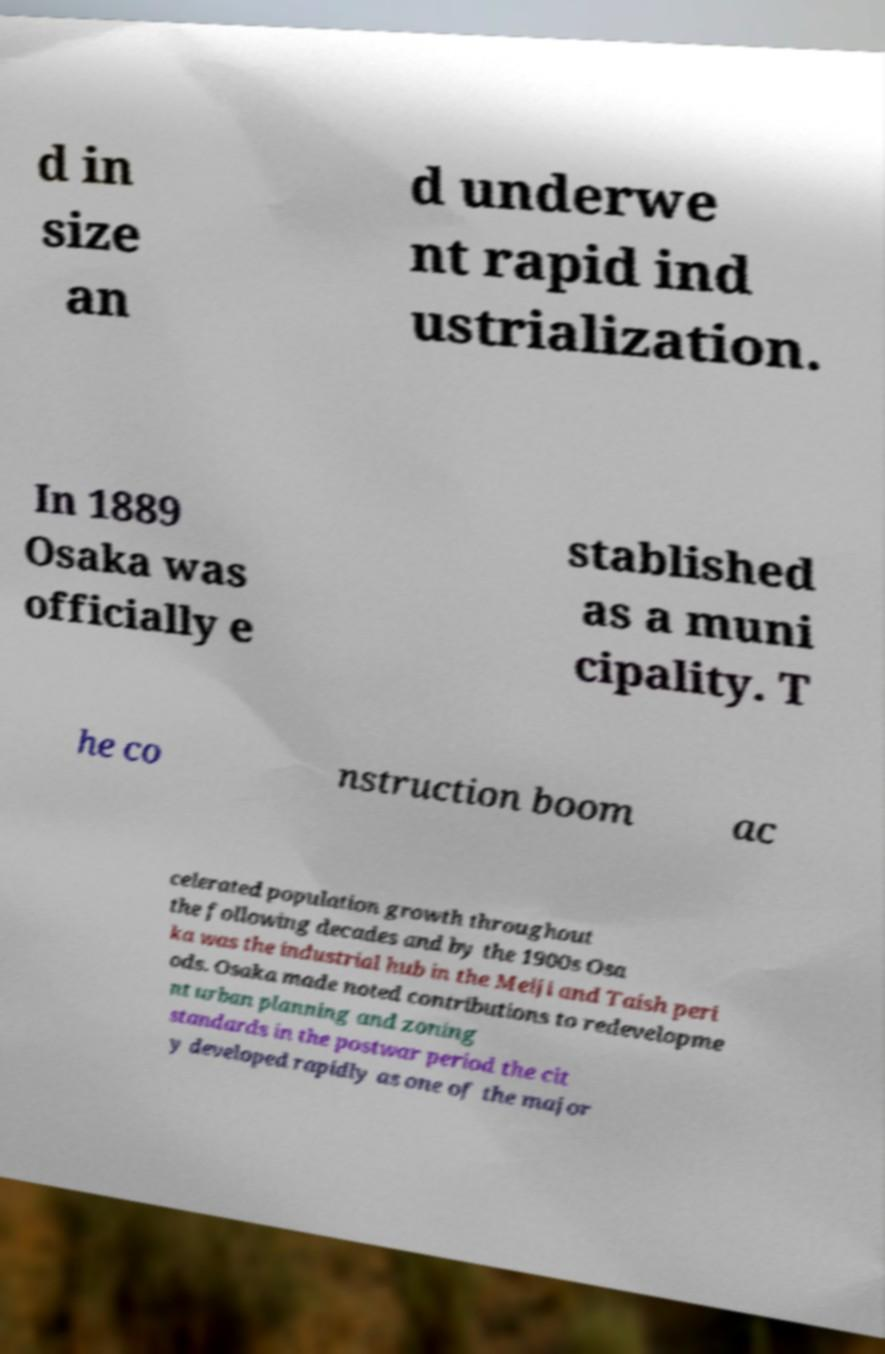There's text embedded in this image that I need extracted. Can you transcribe it verbatim? d in size an d underwe nt rapid ind ustrialization. In 1889 Osaka was officially e stablished as a muni cipality. T he co nstruction boom ac celerated population growth throughout the following decades and by the 1900s Osa ka was the industrial hub in the Meiji and Taish peri ods. Osaka made noted contributions to redevelopme nt urban planning and zoning standards in the postwar period the cit y developed rapidly as one of the major 